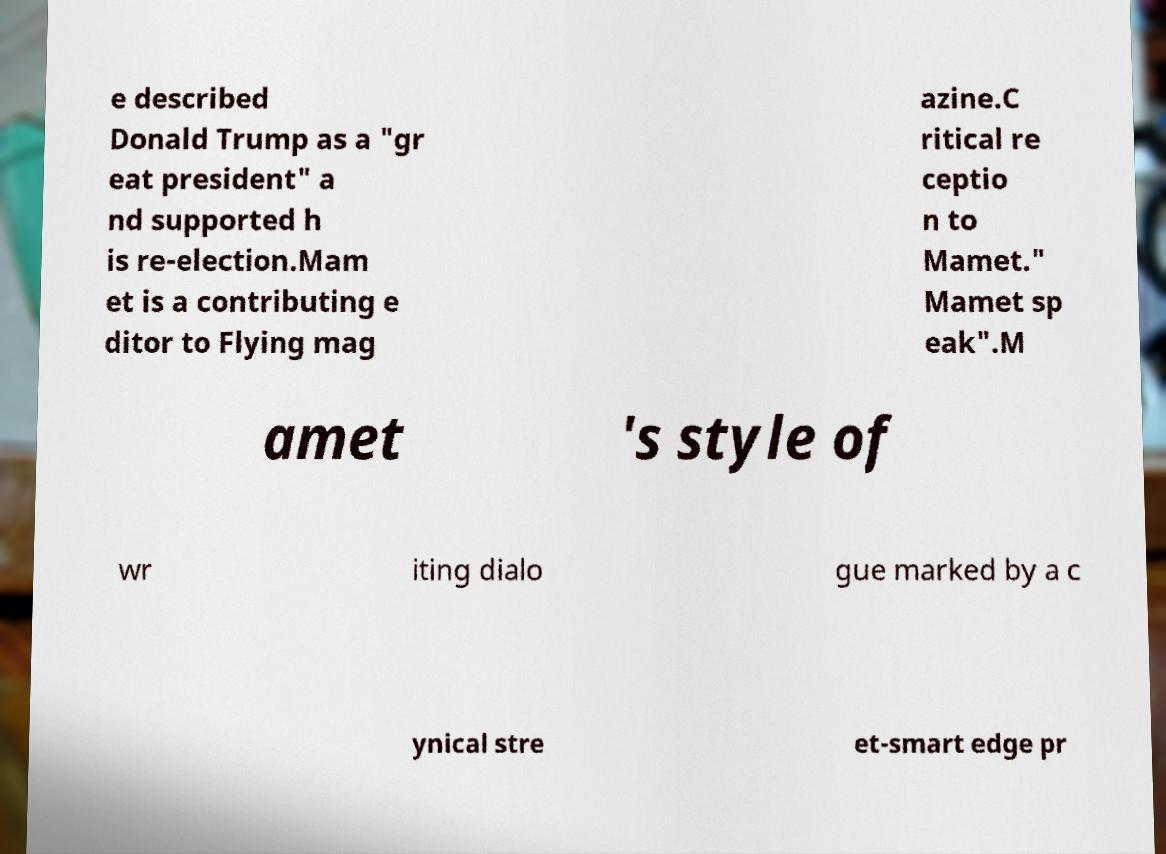Can you read and provide the text displayed in the image?This photo seems to have some interesting text. Can you extract and type it out for me? e described Donald Trump as a "gr eat president" a nd supported h is re-election.Mam et is a contributing e ditor to Flying mag azine.C ritical re ceptio n to Mamet." Mamet sp eak".M amet 's style of wr iting dialo gue marked by a c ynical stre et-smart edge pr 